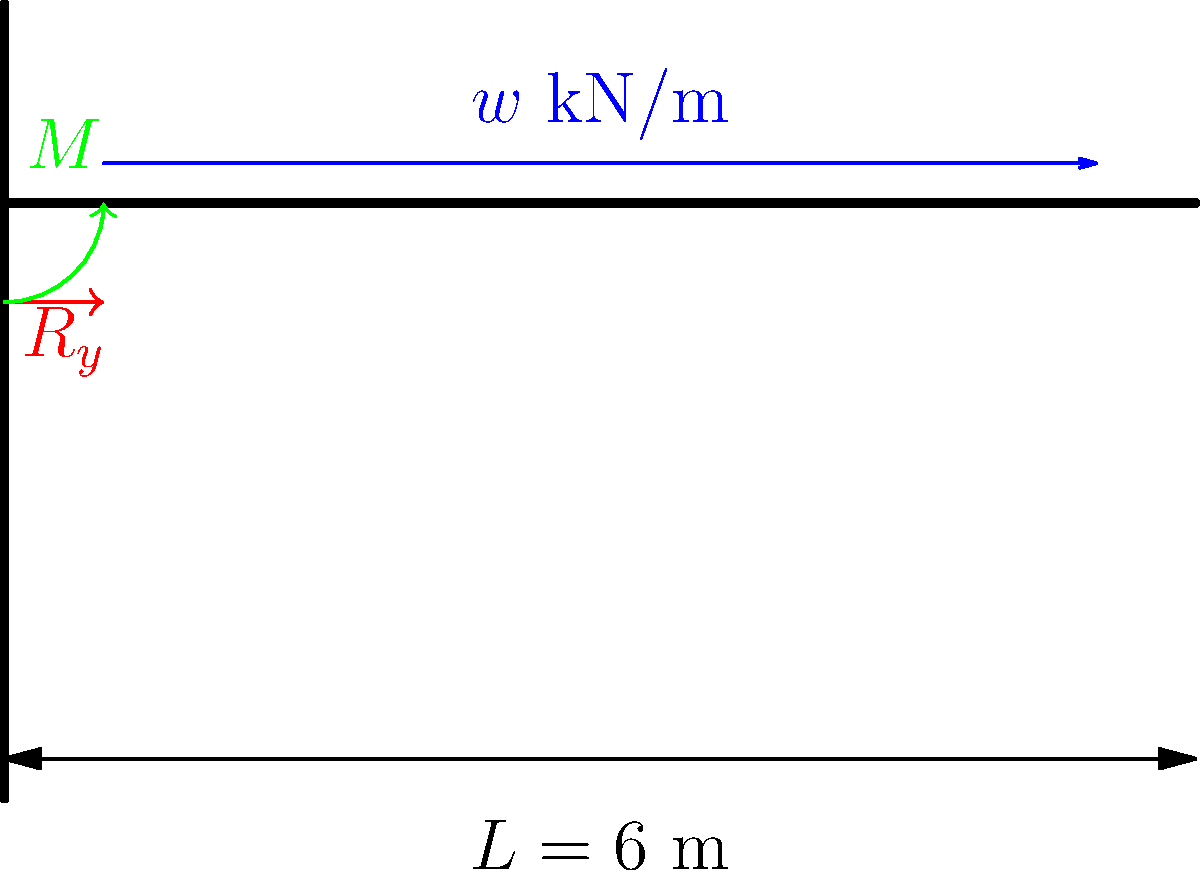For the cantilever beam shown in the diagram, which is typically used in balcony construction, determine the reaction force $R_y$ and moment $M$ at the fixed support. The beam is subjected to a uniformly distributed load of $w = 2$ kN/m along its entire length of 6 meters. To solve this problem, we'll follow these steps:

1) First, let's identify the given information:
   - Beam length, $L = 6$ m
   - Uniformly distributed load, $w = 2$ kN/m

2) For a cantilever beam with a uniformly distributed load, we can use the following formulas:
   - Reaction force: $R_y = wL$
   - Moment at support: $M = \frac{wL^2}{2}$

3) Calculate the reaction force $R_y$:
   $R_y = wL = 2 \text{ kN/m} \times 6 \text{ m} = 12 \text{ kN}$

4) Calculate the moment $M$ at the support:
   $M = \frac{wL^2}{2} = \frac{2 \text{ kN/m} \times (6 \text{ m})^2}{2} = 36 \text{ kN·m}$

5) The reaction force acts upward to balance the downward distributed load, and the moment acts counterclockwise to prevent rotation of the beam.

Therefore, the reaction force at the support is 12 kN upward, and the moment at the support is 36 kN·m counterclockwise.
Answer: $R_y = 12 \text{ kN}$ upward, $M = 36 \text{ kN·m}$ counterclockwise 